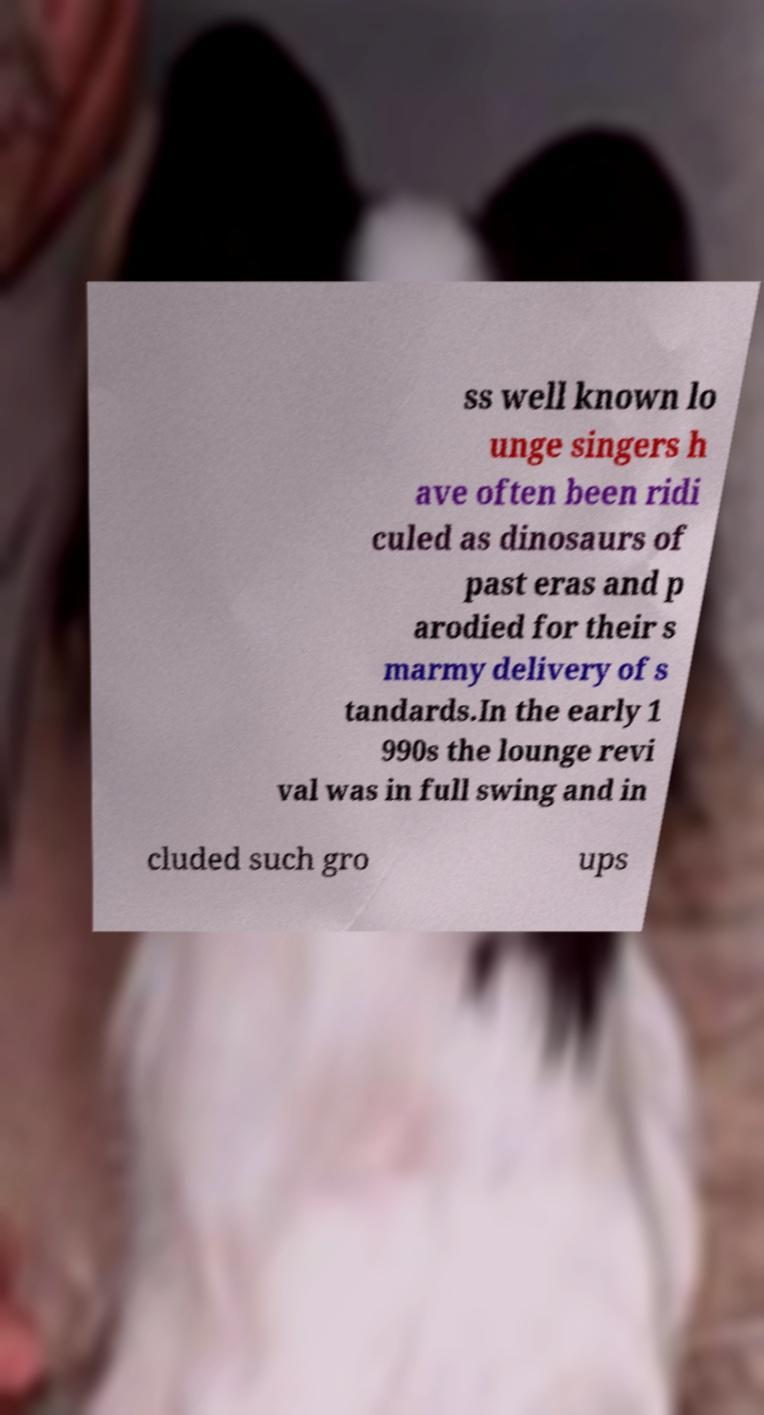Could you extract and type out the text from this image? ss well known lo unge singers h ave often been ridi culed as dinosaurs of past eras and p arodied for their s marmy delivery of s tandards.In the early 1 990s the lounge revi val was in full swing and in cluded such gro ups 